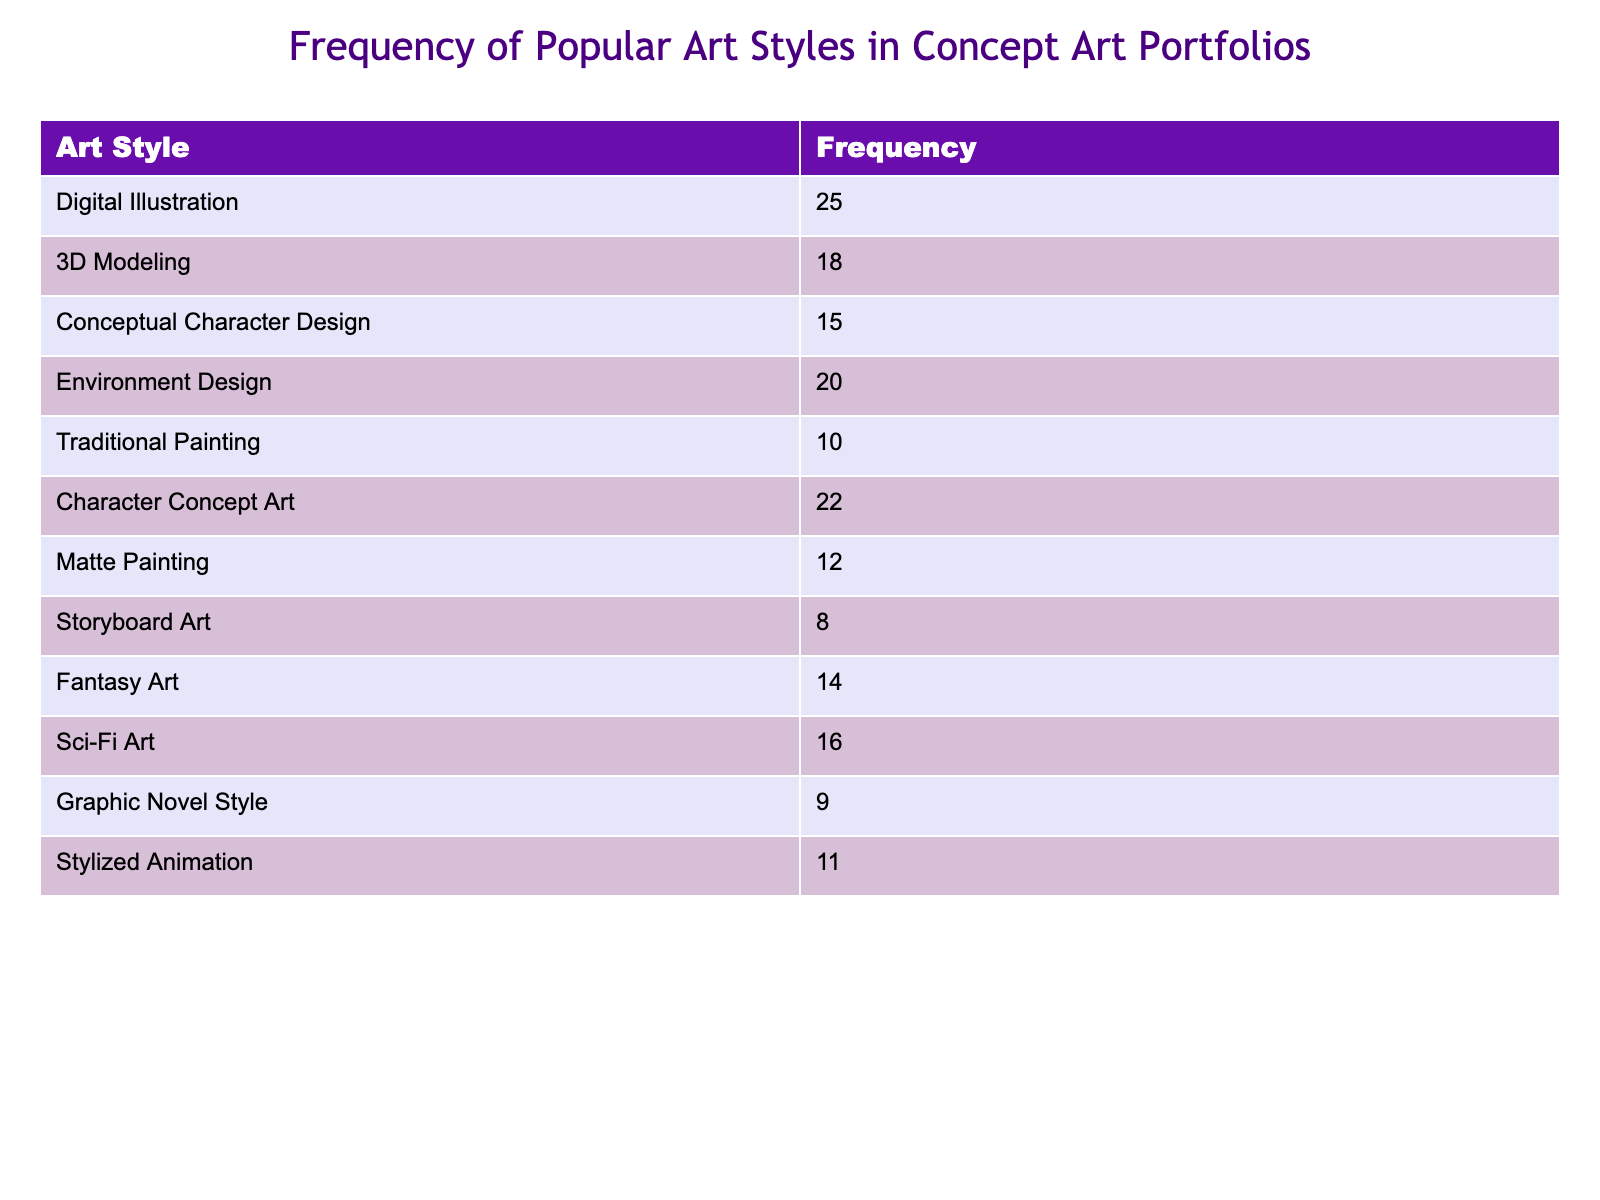What is the most popular art style in concept art portfolios? The table shows the frequency of each art style. By inspecting the 'Frequency' column, we can see that 'Digital Illustration' has the highest frequency at 25.
Answer: Digital Illustration How many more frequencies does Character Concept Art have compared to Traditional Painting? By looking at the frequencies, Character Concept Art has a frequency of 22, while Traditional Painting has a frequency of 10. To find the difference: 22 - 10 = 12.
Answer: 12 Is the frequency of Fantasy Art greater than that of Matte Painting? Checking the table, Fantasy Art has a frequency of 14 and Matte Painting has a frequency of 12. Since 14 is greater than 12, the statement is true.
Answer: Yes What is the total frequency of all art styles listed in the table? To find the total frequency, we sum the values of each frequency: 25 + 18 + 15 + 20 + 10 + 22 + 12 + 8 + 14 + 16 + 9 + 11 =  200.
Answer: 200 What percentage of the total frequency does 3D Modeling represent? First, we note that 3D Modeling has a frequency of 18 out of a total of 200. To find the percentage: (18 / 200) * 100 = 9%.
Answer: 9% Which art styles have a frequency greater than 15? Inspecting the table, the styles with frequencies greater than 15 are Digital Illustration (25), Character Concept Art (22), Environment Design (20), and Sci-Fi Art (16).
Answer: Digital Illustration, Character Concept Art, Environment Design, Sci-Fi Art What is the average frequency of all the art styles listed? To find the average, we sum all the frequencies (200) and divide by the number of art styles (12): 200 / 12 = 16.67 (approximated).
Answer: 16.67 Do more than half of the art styles have a frequency greater than 15? The table lists 12 art styles. The styles with a frequency greater than 15 are Digital Illustration, Character Concept Art, Environment Design, and Sci-Fi Art, totaling 4 styles. Since 4 is less than half of 12, the answer is no.
Answer: No What is the difference in frequency between the least and most popular art styles? The least popular is Storyboard Art with a frequency of 8, and the most popular is Digital Illustration with a frequency of 25. To find the difference: 25 - 8 = 17.
Answer: 17 